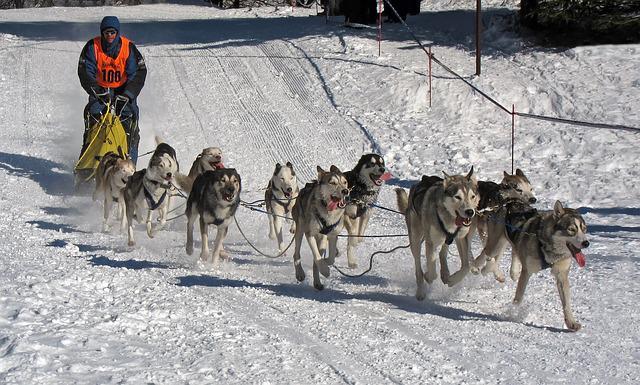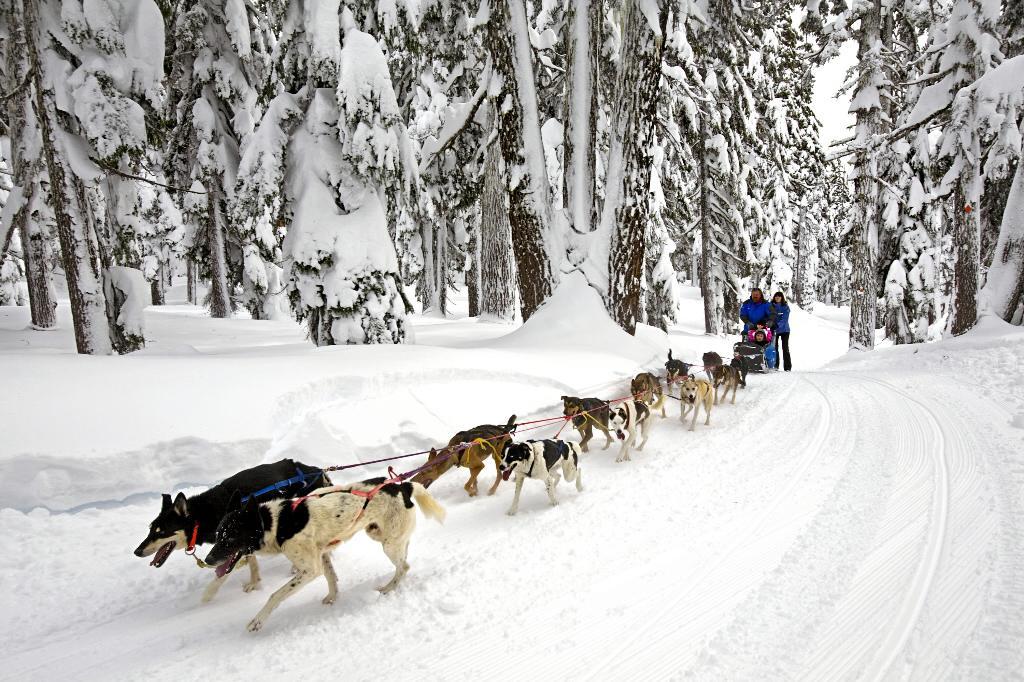The first image is the image on the left, the second image is the image on the right. Assess this claim about the two images: "At least one lead dog clearly has their tongue hanging out.". Correct or not? Answer yes or no. Yes. The first image is the image on the left, the second image is the image on the right. Assess this claim about the two images: "A team of dogs is heading down a path lined with snow-covered trees.". Correct or not? Answer yes or no. Yes. 